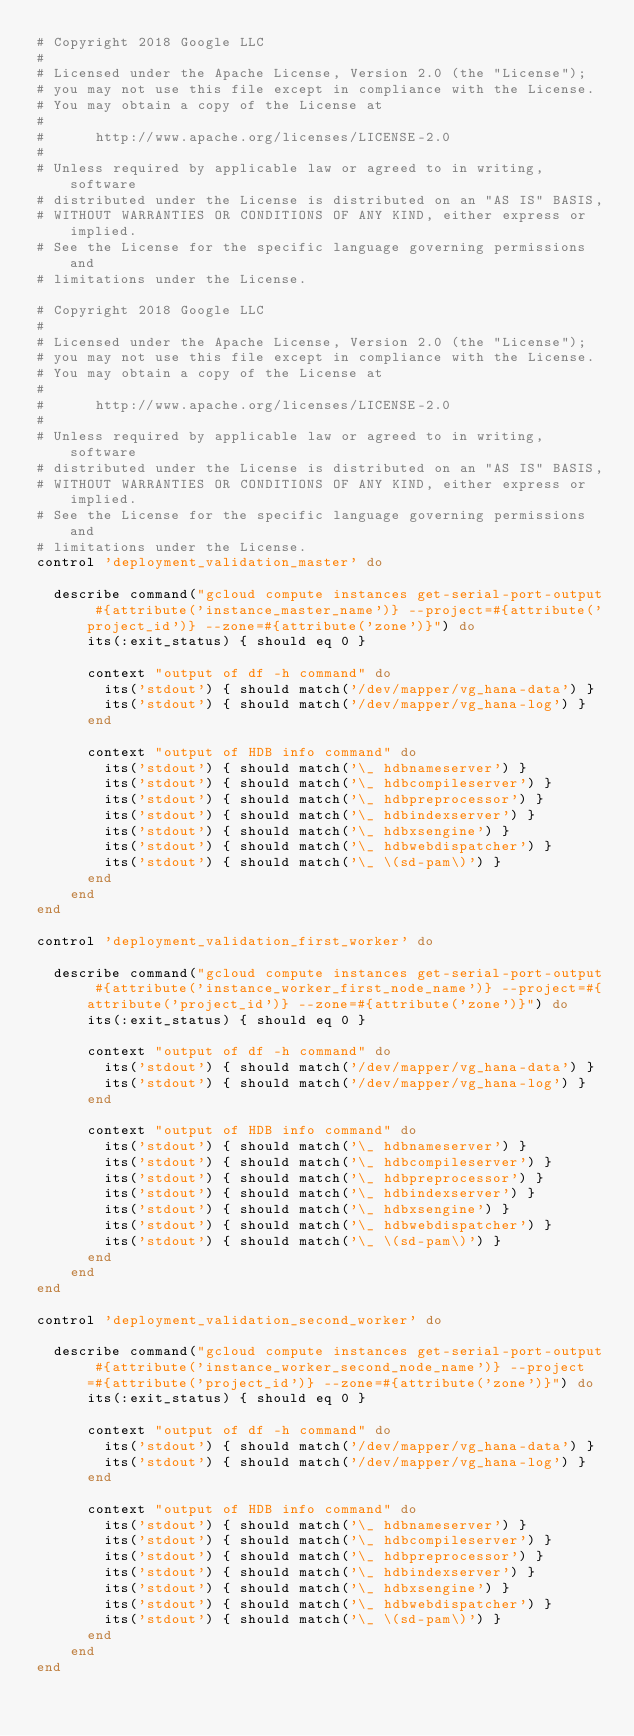Convert code to text. <code><loc_0><loc_0><loc_500><loc_500><_Ruby_># Copyright 2018 Google LLC
#
# Licensed under the Apache License, Version 2.0 (the "License");
# you may not use this file except in compliance with the License.
# You may obtain a copy of the License at
#
#      http://www.apache.org/licenses/LICENSE-2.0
#
# Unless required by applicable law or agreed to in writing, software
# distributed under the License is distributed on an "AS IS" BASIS,
# WITHOUT WARRANTIES OR CONDITIONS OF ANY KIND, either express or implied.
# See the License for the specific language governing permissions and
# limitations under the License.

# Copyright 2018 Google LLC
#
# Licensed under the Apache License, Version 2.0 (the "License");
# you may not use this file except in compliance with the License.
# You may obtain a copy of the License at
#
#      http://www.apache.org/licenses/LICENSE-2.0
#
# Unless required by applicable law or agreed to in writing, software
# distributed under the License is distributed on an "AS IS" BASIS,
# WITHOUT WARRANTIES OR CONDITIONS OF ANY KIND, either express or implied.
# See the License for the specific language governing permissions and
# limitations under the License.
control 'deployment_validation_master' do

  describe command("gcloud compute instances get-serial-port-output #{attribute('instance_master_name')} --project=#{attribute('project_id')} --zone=#{attribute('zone')}") do
      its(:exit_status) { should eq 0 }

      context "output of df -h command" do
        its('stdout') { should match('/dev/mapper/vg_hana-data') }
        its('stdout') { should match('/dev/mapper/vg_hana-log') }
      end

      context "output of HDB info command" do
        its('stdout') { should match('\_ hdbnameserver') }
        its('stdout') { should match('\_ hdbcompileserver') }
        its('stdout') { should match('\_ hdbpreprocessor') }
        its('stdout') { should match('\_ hdbindexserver') }
        its('stdout') { should match('\_ hdbxsengine') }
        its('stdout') { should match('\_ hdbwebdispatcher') }
        its('stdout') { should match('\_ \(sd-pam\)') }
      end
    end
end

control 'deployment_validation_first_worker' do

  describe command("gcloud compute instances get-serial-port-output #{attribute('instance_worker_first_node_name')} --project=#{attribute('project_id')} --zone=#{attribute('zone')}") do
      its(:exit_status) { should eq 0 }

      context "output of df -h command" do
        its('stdout') { should match('/dev/mapper/vg_hana-data') }
        its('stdout') { should match('/dev/mapper/vg_hana-log') }
      end

      context "output of HDB info command" do
        its('stdout') { should match('\_ hdbnameserver') }
        its('stdout') { should match('\_ hdbcompileserver') }
        its('stdout') { should match('\_ hdbpreprocessor') }
        its('stdout') { should match('\_ hdbindexserver') }
        its('stdout') { should match('\_ hdbxsengine') }
        its('stdout') { should match('\_ hdbwebdispatcher') }
        its('stdout') { should match('\_ \(sd-pam\)') }
      end
    end
end

control 'deployment_validation_second_worker' do

  describe command("gcloud compute instances get-serial-port-output #{attribute('instance_worker_second_node_name')} --project=#{attribute('project_id')} --zone=#{attribute('zone')}") do
      its(:exit_status) { should eq 0 }

      context "output of df -h command" do
        its('stdout') { should match('/dev/mapper/vg_hana-data') }
        its('stdout') { should match('/dev/mapper/vg_hana-log') }
      end

      context "output of HDB info command" do
        its('stdout') { should match('\_ hdbnameserver') }
        its('stdout') { should match('\_ hdbcompileserver') }
        its('stdout') { should match('\_ hdbpreprocessor') }
        its('stdout') { should match('\_ hdbindexserver') }
        its('stdout') { should match('\_ hdbxsengine') }
        its('stdout') { should match('\_ hdbwebdispatcher') }
        its('stdout') { should match('\_ \(sd-pam\)') }
      end
    end
end
</code> 